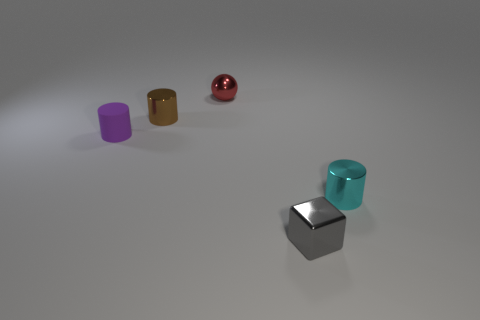Subtract all cyan metal cylinders. How many cylinders are left? 2 Add 1 blue matte blocks. How many objects exist? 6 Subtract all brown cylinders. How many cylinders are left? 2 Subtract all balls. How many objects are left? 4 Subtract all tiny blue objects. Subtract all small shiny cylinders. How many objects are left? 3 Add 2 red balls. How many red balls are left? 3 Add 3 small purple cubes. How many small purple cubes exist? 3 Subtract 0 cyan spheres. How many objects are left? 5 Subtract 1 cylinders. How many cylinders are left? 2 Subtract all yellow balls. Subtract all yellow cylinders. How many balls are left? 1 